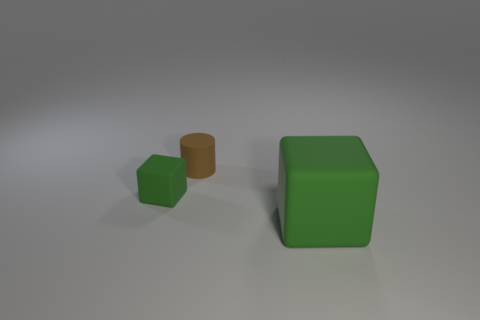Do the big cube and the small block have the same color?
Make the answer very short. Yes. How many cylinders are green rubber things or big brown matte things?
Keep it short and to the point. 0. What color is the cube behind the green rubber thing on the right side of the small green object?
Give a very brief answer. Green. What size is the block that is the same color as the big thing?
Offer a terse response. Small. How many tiny brown rubber cylinders are in front of the green matte object right of the rubber object behind the tiny matte block?
Provide a succinct answer. 0. Does the green thing on the left side of the big cube have the same shape as the small brown rubber object left of the big block?
Your answer should be compact. No. How many things are small objects or gray matte spheres?
Your answer should be compact. 2. Are there any small matte cubes of the same color as the small cylinder?
Offer a very short reply. No. Is the color of the large matte cube the same as the object that is left of the small brown object?
Provide a short and direct response. Yes. How many objects are green cubes right of the small green object or objects that are to the left of the large rubber block?
Ensure brevity in your answer.  3. 